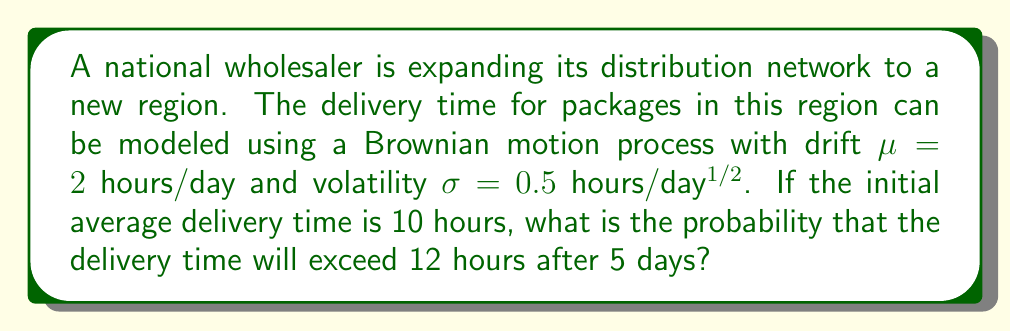Give your solution to this math problem. To solve this problem, we'll use the properties of Brownian motion with drift:

1) The mean (expected value) of the delivery time after t days is:
   $$E[X_t] = X_0 + \mu t$$
   where $X_0$ is the initial delivery time.

2) The variance of the delivery time after t days is:
   $$Var[X_t] = \sigma^2 t$$

3) The delivery time follows a normal distribution:
   $$X_t \sim N(X_0 + \mu t, \sigma^2 t)$$

4) For our problem:
   $X_0 = 10$ hours
   $\mu = 2$ hours/day
   $\sigma = 0.5$ hours/day$^{1/2}$
   $t = 5$ days

5) Calculate the mean after 5 days:
   $$E[X_5] = 10 + 2 \cdot 5 = 20$$ hours

6) Calculate the variance after 5 days:
   $$Var[X_5] = 0.5^2 \cdot 5 = 1.25$$ hours$^2$

7) The standard deviation is:
   $$\sqrt{Var[X_5]} = \sqrt{1.25} \approx 1.118$$ hours

8) We want to find $P(X_5 > 12)$. Standardize this:
   $$Z = \frac{12 - 20}{1.118} \approx -7.156$$

9) Use the standard normal distribution to find:
   $$P(X_5 > 12) = P(Z > -7.156) = 1 - P(Z < -7.156) \approx 1 - 0 = 1$$

The probability is effectively 1 (or 100%) when rounded to standard decimal places.
Answer: $\approx 1$ or 100% 